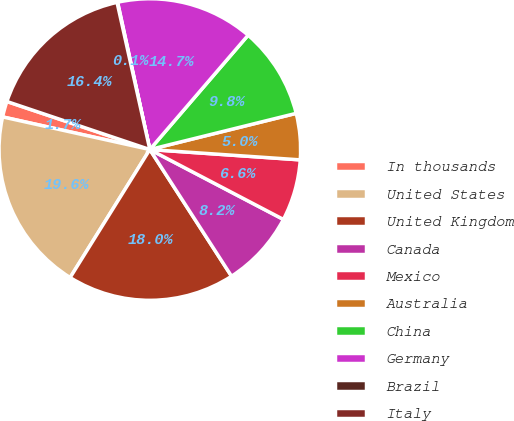Convert chart. <chart><loc_0><loc_0><loc_500><loc_500><pie_chart><fcel>In thousands<fcel>United States<fcel>United Kingdom<fcel>Canada<fcel>Mexico<fcel>Australia<fcel>China<fcel>Germany<fcel>Brazil<fcel>Italy<nl><fcel>1.69%<fcel>19.61%<fcel>17.98%<fcel>8.21%<fcel>6.58%<fcel>4.95%<fcel>9.84%<fcel>14.73%<fcel>0.06%<fcel>16.35%<nl></chart> 